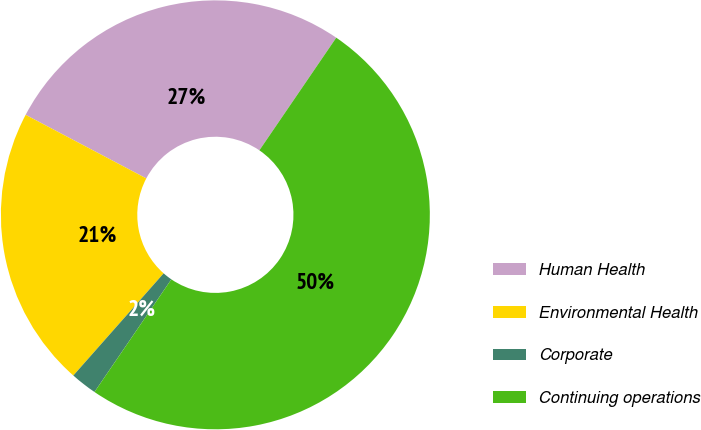<chart> <loc_0><loc_0><loc_500><loc_500><pie_chart><fcel>Human Health<fcel>Environmental Health<fcel>Corporate<fcel>Continuing operations<nl><fcel>26.81%<fcel>21.2%<fcel>1.99%<fcel>50.0%<nl></chart> 